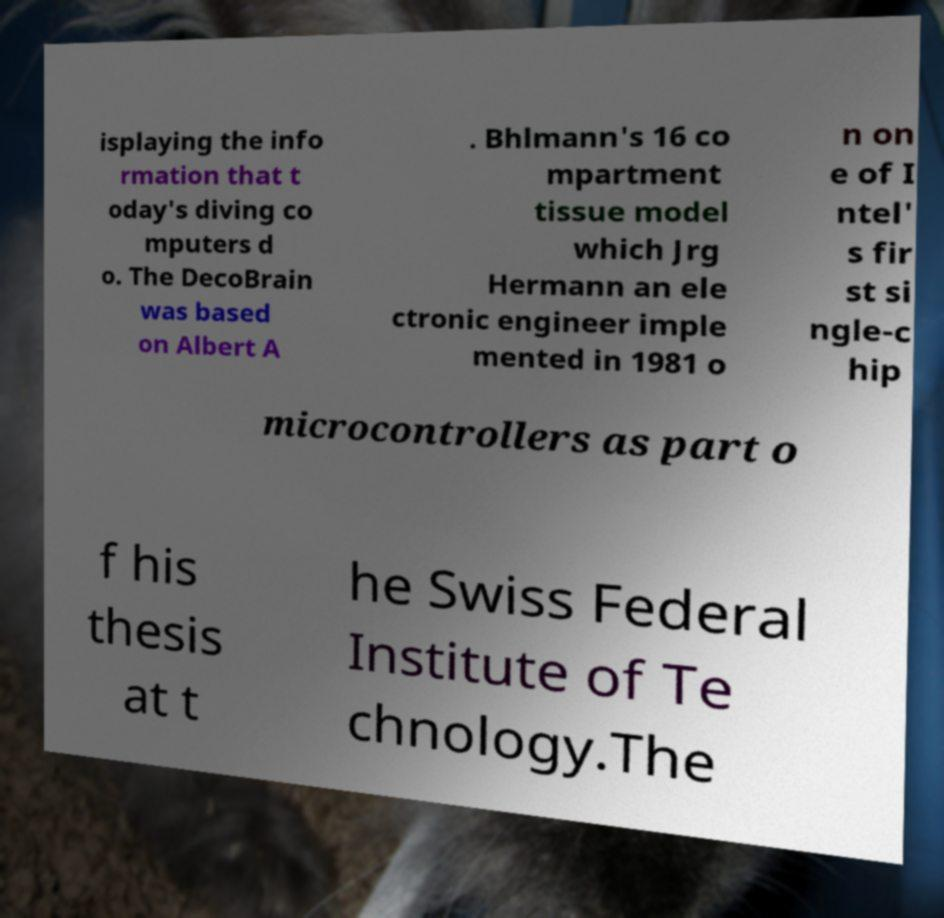Please read and relay the text visible in this image. What does it say? isplaying the info rmation that t oday's diving co mputers d o. The DecoBrain was based on Albert A . Bhlmann's 16 co mpartment tissue model which Jrg Hermann an ele ctronic engineer imple mented in 1981 o n on e of I ntel' s fir st si ngle-c hip microcontrollers as part o f his thesis at t he Swiss Federal Institute of Te chnology.The 